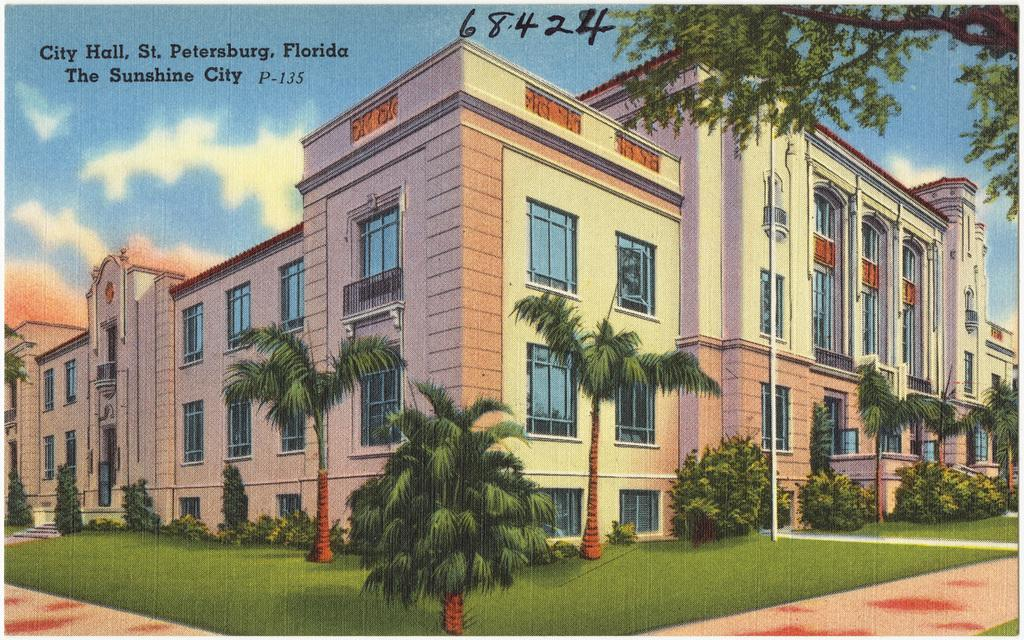What is the medium of the image? The image is printed. What is the main subject of the image? There is a city hall in the image. What type of vegetation is present around the city hall? There are trees and grass around the city hall. How many windows does the city hall have? The city hall has many windows. How many doors does the city hall have? The city hall has many doors. What type of brake is installed on the zebra in the image? There is no zebra present in the image, and therefore no brake can be observed. 